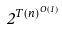Convert formula to latex. <formula><loc_0><loc_0><loc_500><loc_500>2 ^ { T ( n ) ^ { O ( 1 ) } }</formula> 